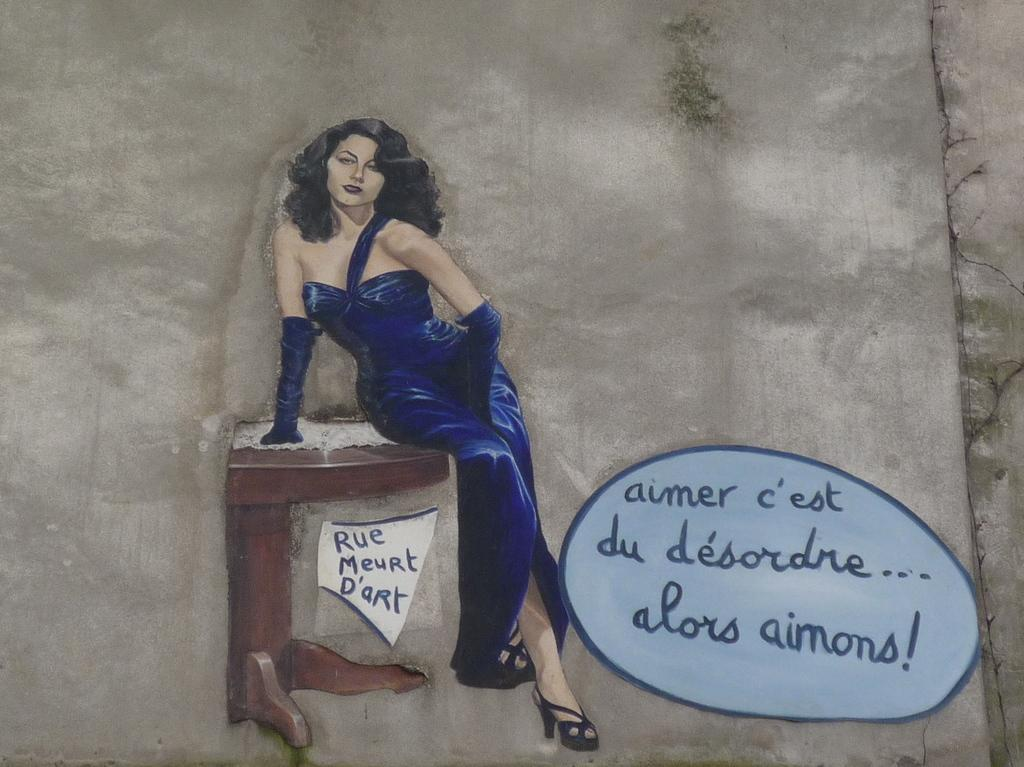Who is the main subject in the image? There is a woman in the image. What is the woman wearing? The woman is wearing a blue skirt. What is the woman doing in the image? The woman is sitting on a bench. What can be seen on the right side of the image? There is text on the right side of the image. How is the image created? The image appears to be a drawing. What type of stone is the woman using to process her point in the image? There is no stone or process mentioned in the image; it features a woman sitting on a bench with text on the right side. 